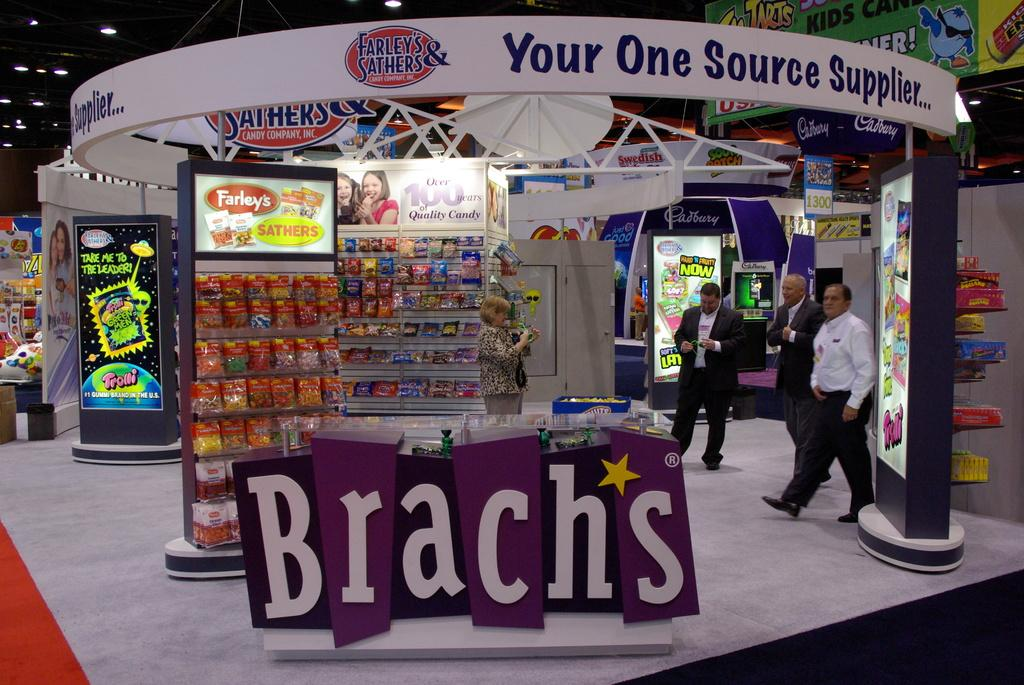Provide a one-sentence caption for the provided image. A Brach's candy display has a colorful purple sign. 